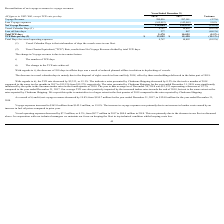From Nordic American Tankers Limited's financial document, What are the respective voyage revenue in 2017 and 2018? The document shows two values: 297,141 and 289,016 (in thousands). From the document: "Voyage Revenue 289,016 297,141 (2.7%) Voyage Revenue 289,016 297,141 (2.7%)..." Also, What are the respective voyage expenses in 2017 and 2018? The document shows two values: 142,465 and 165,012 (in thousands). From the document: "Less Voyage expenses (165,012) (142,465) 15.8% Less Voyage expenses (165,012) (142,465) 15.8%..." Also, What are the respective net voyage revenue in 2017 and 2018? The document shows two values: 154,676 and 124,004 (in thousands). From the document: "Net Voyage Revenue 124,004 154,676 (19.8%) Net Voyage Revenue 124,004 154,676 (19.8%)..." Also, can you calculate: What is the value of the voyage revenue in 2017 as a percentage of the revenue in 2018? Based on the calculation: 297,141/289,016 , the result is 102.81 (percentage). This is based on the information: "Voyage Revenue 289,016 297,141 (2.7%) Voyage Revenue 289,016 297,141 (2.7%)..." The key data points involved are: 289,016, 297,141. Also, can you calculate: What is the value of the voyage expenses in 2017 as a percentage of the expenses in 2018? Based on the calculation: 142,465/165,012 , the result is 86.34 (percentage). This is based on the information: "Less Voyage expenses (165,012) (142,465) 15.8% Less Voyage expenses (165,012) (142,465) 15.8%..." The key data points involved are: 142,465, 165,012. Also, can you calculate: What is the value of the net voyage revenue in 2017 as a percentage of the net voyage revenue in 2018? Based on the calculation: 154,676/124,004 , the result is 124.73 (percentage). This is based on the information: "Net Voyage Revenue 124,004 154,676 (19.8%) Net Voyage Revenue 124,004 154,676 (19.8%)..." The key data points involved are: 124,004, 154,676. 